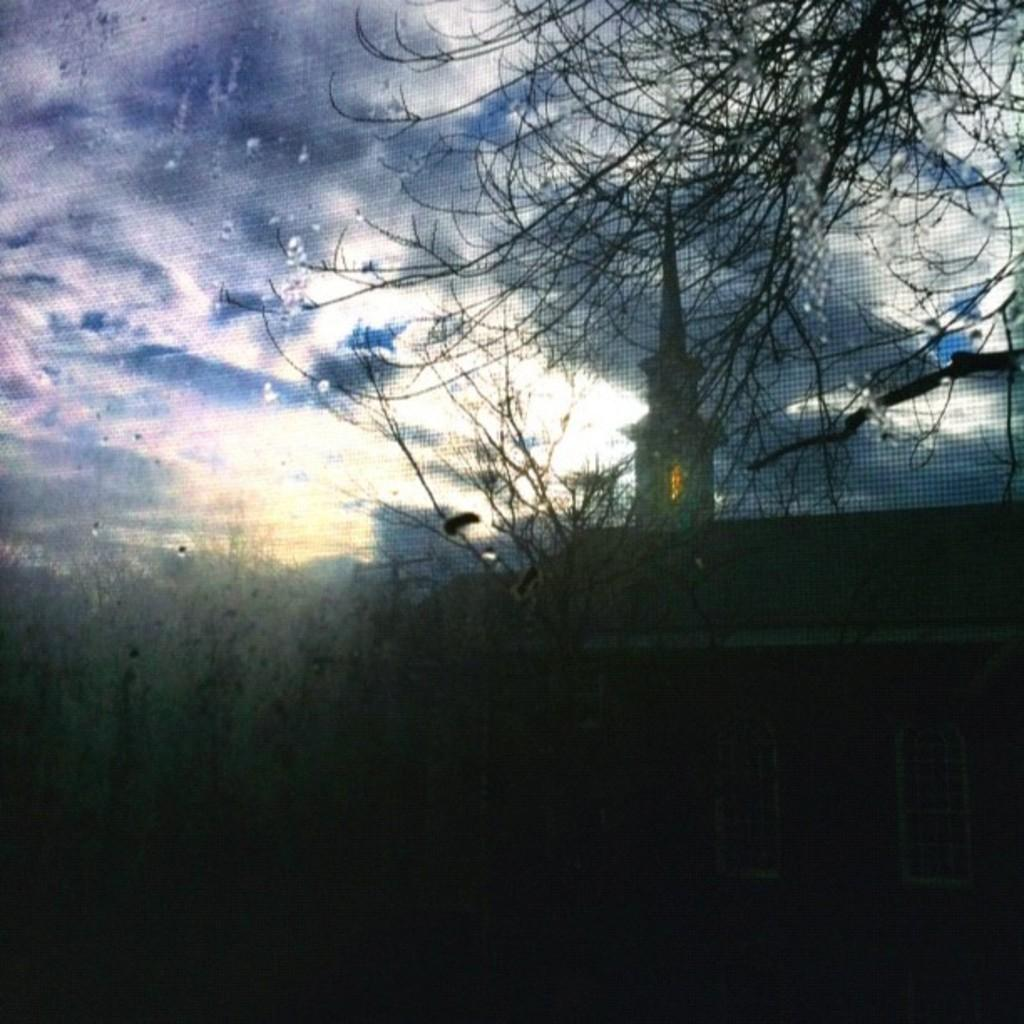What type of vegetation is in the foreground of the image? There are trees in the foreground of the image. What structure can be seen on the right side of the image? There is a building on the right side of the image. What is visible at the top of the image? The sky is visible at the top of the image. What can be observed in the sky? Clouds are present in the sky. What type of sound can be heard coming from the building in the image? There is no information about any sounds in the image, so it is not possible to determine what, if any, sound might be heard. 